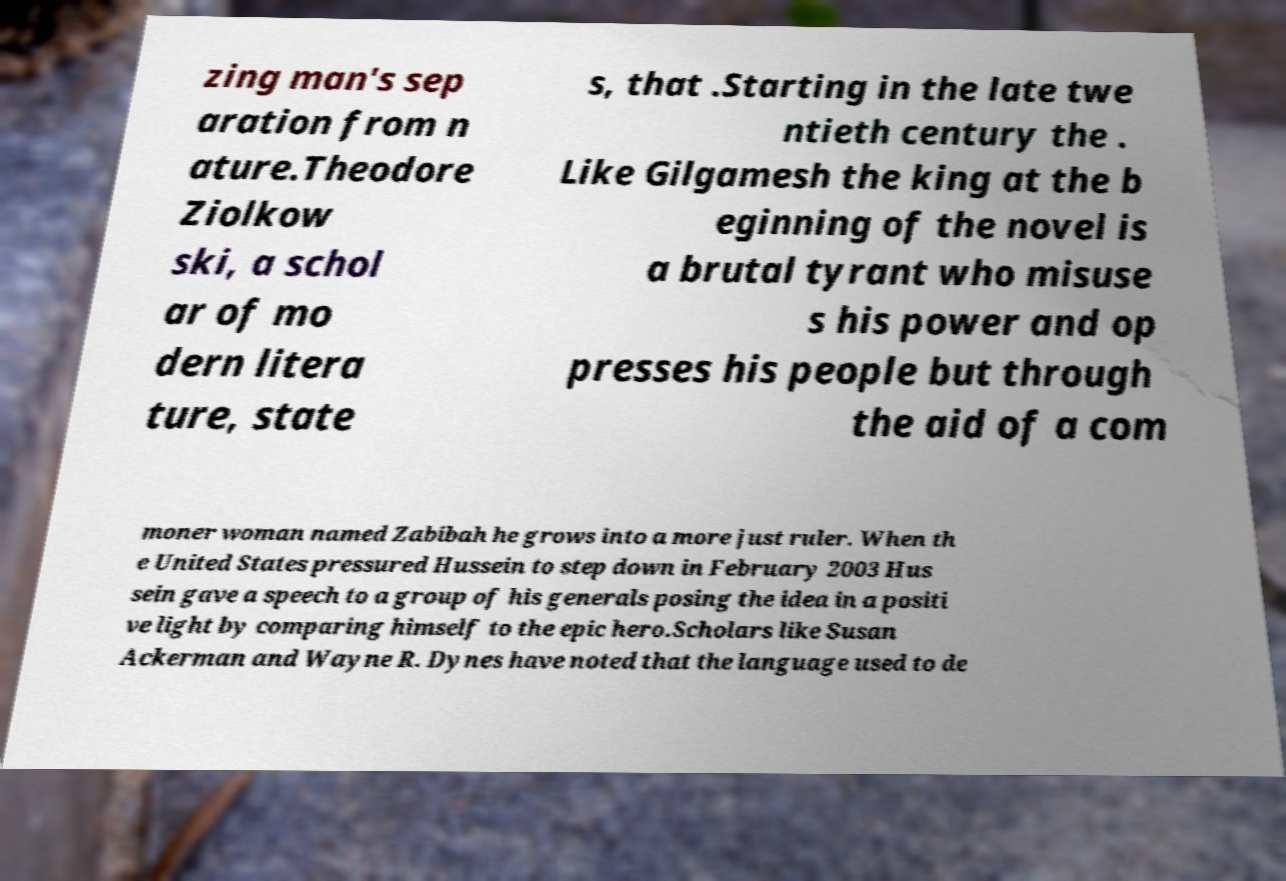For documentation purposes, I need the text within this image transcribed. Could you provide that? zing man's sep aration from n ature.Theodore Ziolkow ski, a schol ar of mo dern litera ture, state s, that .Starting in the late twe ntieth century the . Like Gilgamesh the king at the b eginning of the novel is a brutal tyrant who misuse s his power and op presses his people but through the aid of a com moner woman named Zabibah he grows into a more just ruler. When th e United States pressured Hussein to step down in February 2003 Hus sein gave a speech to a group of his generals posing the idea in a positi ve light by comparing himself to the epic hero.Scholars like Susan Ackerman and Wayne R. Dynes have noted that the language used to de 